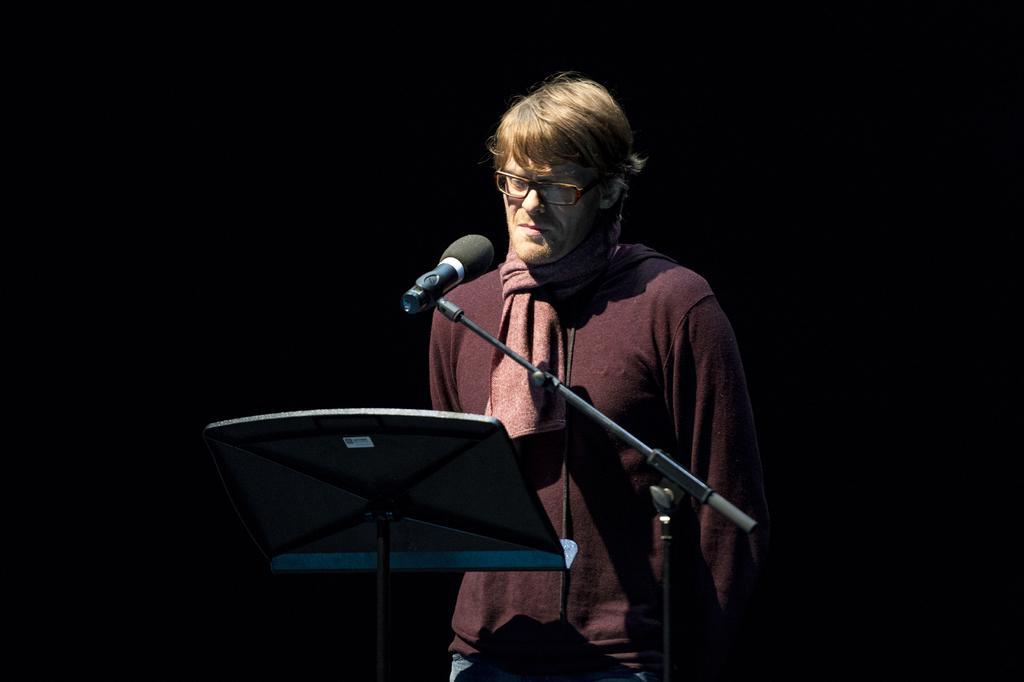Can you describe this image briefly? In this image, I can see the man standing. This is a mile, which is attached to a mike stand. It might be a musical stand. The background looks dark. 